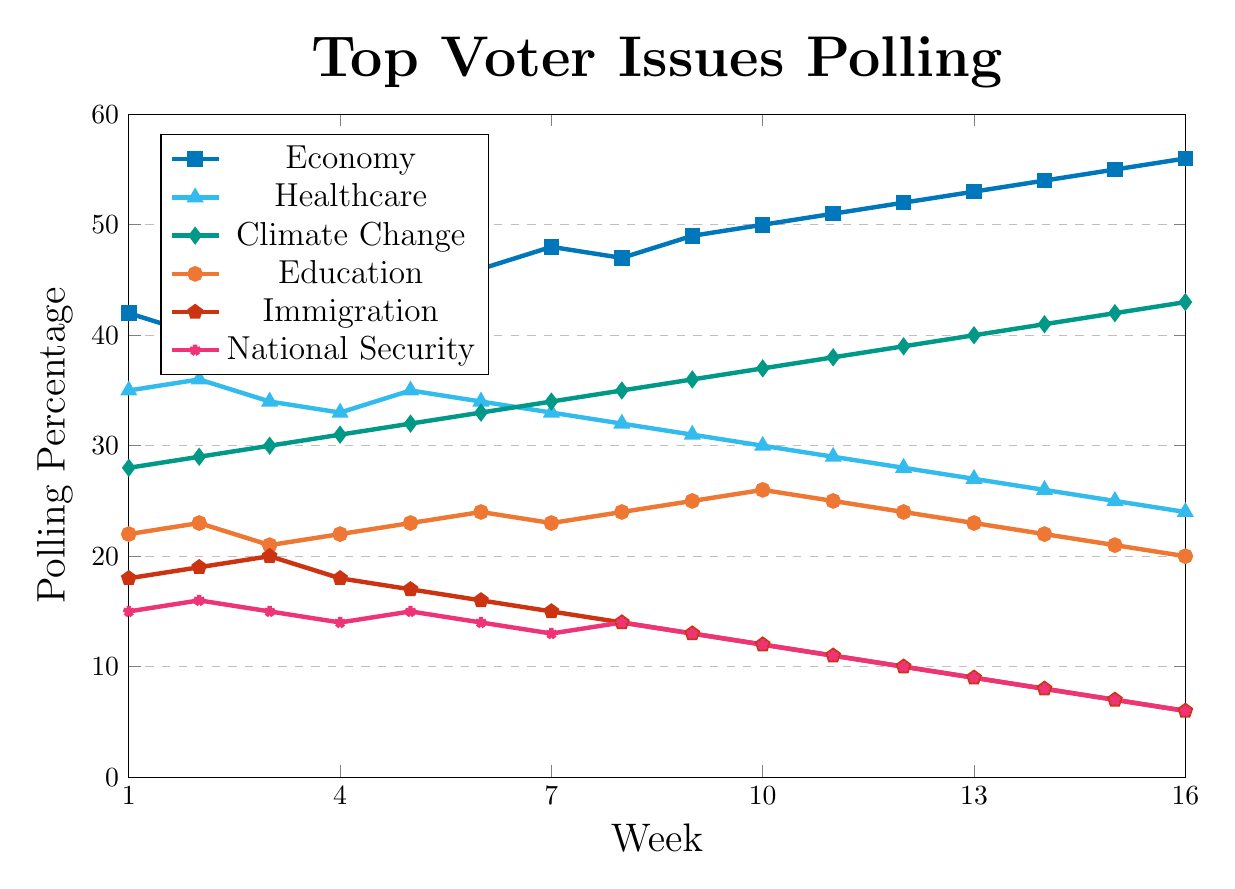Which issue has the highest polling percentage in Week 5? In Week 5, look at the data points to find the highest polling percentage among all issues. The Economy has a polling percentage of 44, which is the highest compared to Healthcare (35), Climate Change (32), Education (23), Immigration (17), and National Security (15).
Answer: Economy How many points did the Economy rise from Week 1 to Week 16? Find the polling percentage of the Economy in Week 1 (42) and Week 16 (56). The increase is 56 - 42.
Answer: 14 Which issues had a polling percentage of 24 in any week? Observe the polling trends for all issues and identify which ones had a polling percentage of 24 at any week. Healthcare had a polling percentage of 24 in Week 16 and Education had 24 in Weeks 6 and 12.
Answer: Healthcare, Education What is the average polling percentage of Climate Change from Week 1 to Week 16? Sum the percentages for Climate Change from Week 1 to Week 16 (28, 29, 30, 31, 32, 33, 34, 35, 36, 37, 38, 39, 40, 41, 42, 43) and divide by the number of weeks (16). The sum is 608, so the average is 608/16.
Answer: 38 Between Weeks 8 and 10, how did Education's polling percentage change? Observe the data points for Education in Weeks 8 (24), 9 (25), and 10 (26). It increased by 2 points from 24 to 26.
Answer: Increased by 2 Which issue saw a continuous rise from Week 1 to Week 16? Identify the issue that had an uninterrupted increase in polling percentage from Week 1 to Week 16. Climate Change polling data shows an increase every week from 28 in Week 1 to 43 in Week 16.
Answer: Climate Change Between Weeks 1 and 10, which issue dropped the most in its polling percentage? Calculate the differences in polling percentages from Week 1 to Week 10 for all issues: Immigration (18 to 12, decrease by 6), National Security (15 to 12, decrease by 3), Healthcare (35 to 30, decrease by 5), and Education (22 to 26, no decrease). Immigration shows the largest drop.
Answer: Immigration How much more popular was the Economy than National Security in Week 11? Subtract the polling percentage of National Security (11) from the Economy (51) in Week 11. The difference is 51 - 11.
Answer: 40 Which issue had the steepest decline from Week 1 to Week 16? Calculate the changes in polling percentages from Week 1 to Week 16 for all issues: Immigration (18 to 6, decrease by 12), National Security (15 to 6, decrease by 9), Healthcare (35 to 24, decrease by 11), Education (22 to 20, decrease by 2). Immigration had the steepest decline of 12 points.
Answer: Immigration 